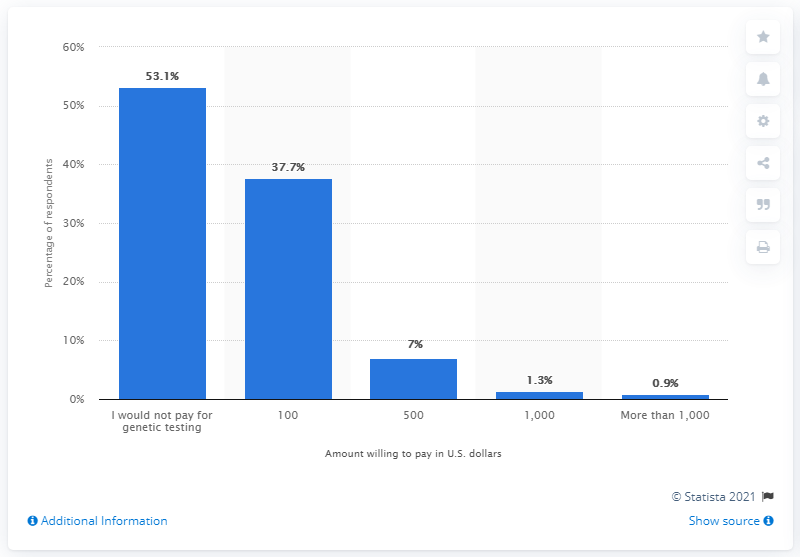What percentage of respondents are not willing to pay for genetic testing? The bar chart shows that 53.1 percent of the respondents are not willing to pay for genetic testing. 